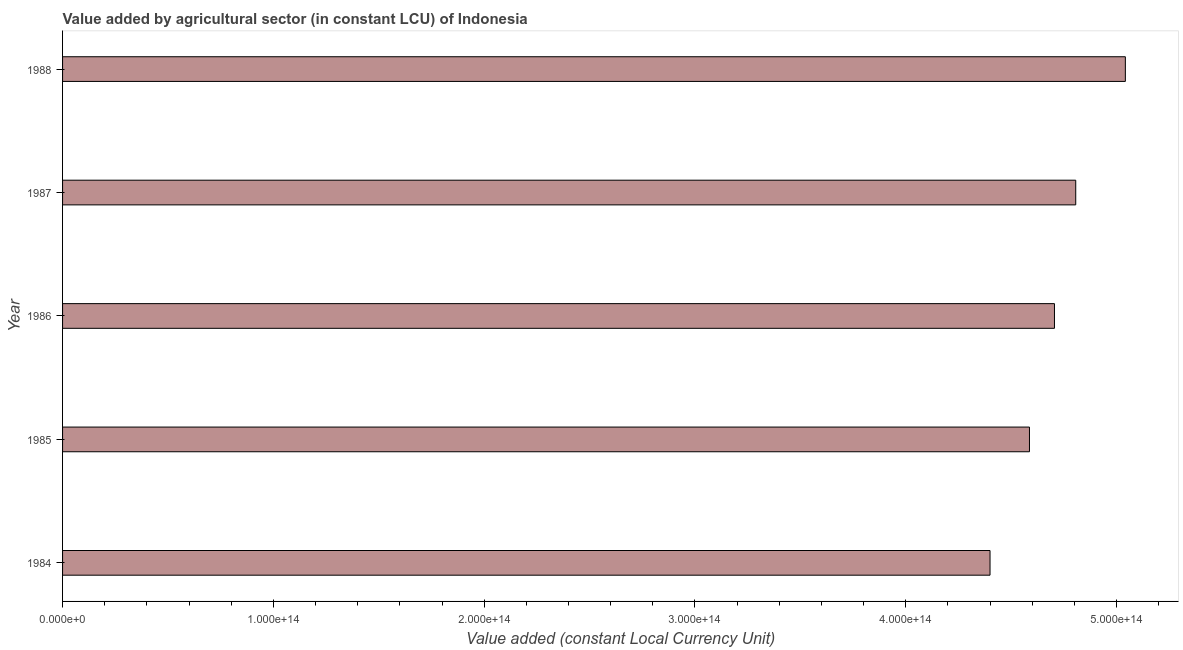Does the graph contain any zero values?
Keep it short and to the point. No. What is the title of the graph?
Keep it short and to the point. Value added by agricultural sector (in constant LCU) of Indonesia. What is the label or title of the X-axis?
Your answer should be very brief. Value added (constant Local Currency Unit). What is the label or title of the Y-axis?
Offer a terse response. Year. What is the value added by agriculture sector in 1986?
Give a very brief answer. 4.71e+14. Across all years, what is the maximum value added by agriculture sector?
Keep it short and to the point. 5.04e+14. Across all years, what is the minimum value added by agriculture sector?
Give a very brief answer. 4.40e+14. In which year was the value added by agriculture sector maximum?
Make the answer very short. 1988. In which year was the value added by agriculture sector minimum?
Your answer should be compact. 1984. What is the sum of the value added by agriculture sector?
Your response must be concise. 2.35e+15. What is the difference between the value added by agriculture sector in 1984 and 1985?
Your answer should be compact. -1.87e+13. What is the average value added by agriculture sector per year?
Your answer should be very brief. 4.71e+14. What is the median value added by agriculture sector?
Keep it short and to the point. 4.71e+14. In how many years, is the value added by agriculture sector greater than 120000000000000 LCU?
Give a very brief answer. 5. What is the ratio of the value added by agriculture sector in 1987 to that in 1988?
Your answer should be very brief. 0.95. Is the difference between the value added by agriculture sector in 1984 and 1986 greater than the difference between any two years?
Keep it short and to the point. No. What is the difference between the highest and the second highest value added by agriculture sector?
Offer a very short reply. 2.35e+13. Is the sum of the value added by agriculture sector in 1985 and 1988 greater than the maximum value added by agriculture sector across all years?
Offer a terse response. Yes. What is the difference between the highest and the lowest value added by agriculture sector?
Offer a very short reply. 6.42e+13. In how many years, is the value added by agriculture sector greater than the average value added by agriculture sector taken over all years?
Your answer should be compact. 2. How many bars are there?
Your answer should be very brief. 5. Are all the bars in the graph horizontal?
Give a very brief answer. Yes. How many years are there in the graph?
Offer a very short reply. 5. What is the difference between two consecutive major ticks on the X-axis?
Provide a succinct answer. 1.00e+14. Are the values on the major ticks of X-axis written in scientific E-notation?
Keep it short and to the point. Yes. What is the Value added (constant Local Currency Unit) in 1984?
Your response must be concise. 4.40e+14. What is the Value added (constant Local Currency Unit) in 1985?
Your answer should be compact. 4.59e+14. What is the Value added (constant Local Currency Unit) of 1986?
Offer a terse response. 4.71e+14. What is the Value added (constant Local Currency Unit) of 1987?
Ensure brevity in your answer.  4.81e+14. What is the Value added (constant Local Currency Unit) of 1988?
Provide a short and direct response. 5.04e+14. What is the difference between the Value added (constant Local Currency Unit) in 1984 and 1985?
Provide a short and direct response. -1.87e+13. What is the difference between the Value added (constant Local Currency Unit) in 1984 and 1986?
Provide a short and direct response. -3.06e+13. What is the difference between the Value added (constant Local Currency Unit) in 1984 and 1987?
Make the answer very short. -4.07e+13. What is the difference between the Value added (constant Local Currency Unit) in 1984 and 1988?
Your answer should be very brief. -6.42e+13. What is the difference between the Value added (constant Local Currency Unit) in 1985 and 1986?
Keep it short and to the point. -1.19e+13. What is the difference between the Value added (constant Local Currency Unit) in 1985 and 1987?
Your answer should be very brief. -2.19e+13. What is the difference between the Value added (constant Local Currency Unit) in 1985 and 1988?
Keep it short and to the point. -4.55e+13. What is the difference between the Value added (constant Local Currency Unit) in 1986 and 1987?
Provide a short and direct response. -1.01e+13. What is the difference between the Value added (constant Local Currency Unit) in 1986 and 1988?
Offer a very short reply. -3.36e+13. What is the difference between the Value added (constant Local Currency Unit) in 1987 and 1988?
Give a very brief answer. -2.35e+13. What is the ratio of the Value added (constant Local Currency Unit) in 1984 to that in 1986?
Keep it short and to the point. 0.94. What is the ratio of the Value added (constant Local Currency Unit) in 1984 to that in 1987?
Ensure brevity in your answer.  0.92. What is the ratio of the Value added (constant Local Currency Unit) in 1984 to that in 1988?
Your answer should be compact. 0.87. What is the ratio of the Value added (constant Local Currency Unit) in 1985 to that in 1986?
Your answer should be very brief. 0.97. What is the ratio of the Value added (constant Local Currency Unit) in 1985 to that in 1987?
Provide a succinct answer. 0.95. What is the ratio of the Value added (constant Local Currency Unit) in 1985 to that in 1988?
Make the answer very short. 0.91. What is the ratio of the Value added (constant Local Currency Unit) in 1986 to that in 1988?
Provide a short and direct response. 0.93. What is the ratio of the Value added (constant Local Currency Unit) in 1987 to that in 1988?
Your answer should be compact. 0.95. 